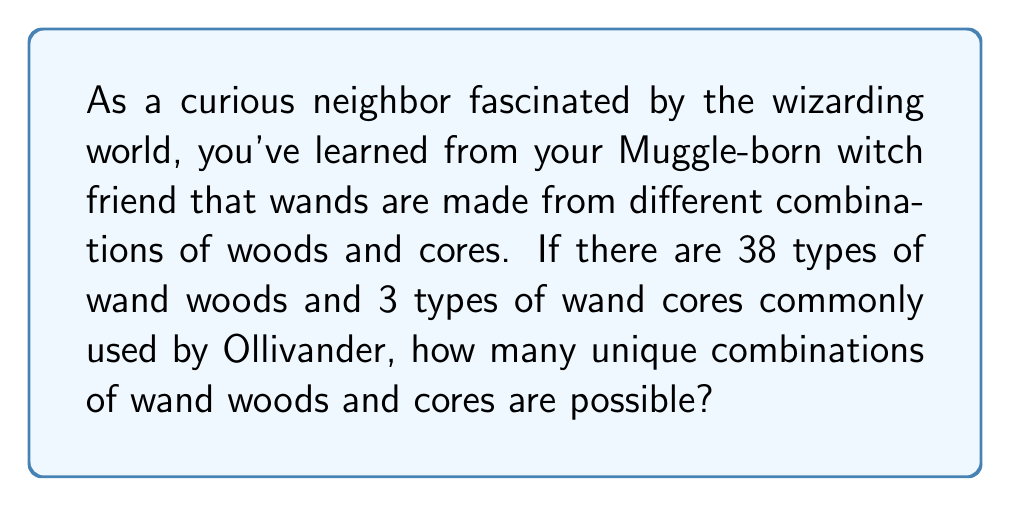Teach me how to tackle this problem. To solve this problem, we need to use the multiplication principle of counting. This principle states that if we have two independent choices, where the first choice has $m$ options and the second choice has $n$ options, then the total number of possible combinations is $m \times n$.

In this case:
1. We have 38 types of wand woods (first choice)
2. We have 3 types of wand cores (second choice)

Each wood can be paired with any of the cores, and each combination is unique. Therefore, we multiply the number of options for each choice:

$$\text{Total combinations} = \text{Number of woods} \times \text{Number of cores}$$

$$\text{Total combinations} = 38 \times 3$$

$$\text{Total combinations} = 114$$

This means that there are 114 unique combinations of wand woods and cores possible.
Answer: $114$ unique combinations 